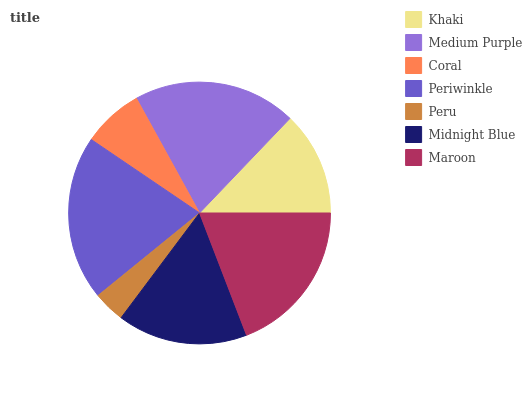Is Peru the minimum?
Answer yes or no. Yes. Is Periwinkle the maximum?
Answer yes or no. Yes. Is Medium Purple the minimum?
Answer yes or no. No. Is Medium Purple the maximum?
Answer yes or no. No. Is Medium Purple greater than Khaki?
Answer yes or no. Yes. Is Khaki less than Medium Purple?
Answer yes or no. Yes. Is Khaki greater than Medium Purple?
Answer yes or no. No. Is Medium Purple less than Khaki?
Answer yes or no. No. Is Midnight Blue the high median?
Answer yes or no. Yes. Is Midnight Blue the low median?
Answer yes or no. Yes. Is Medium Purple the high median?
Answer yes or no. No. Is Medium Purple the low median?
Answer yes or no. No. 